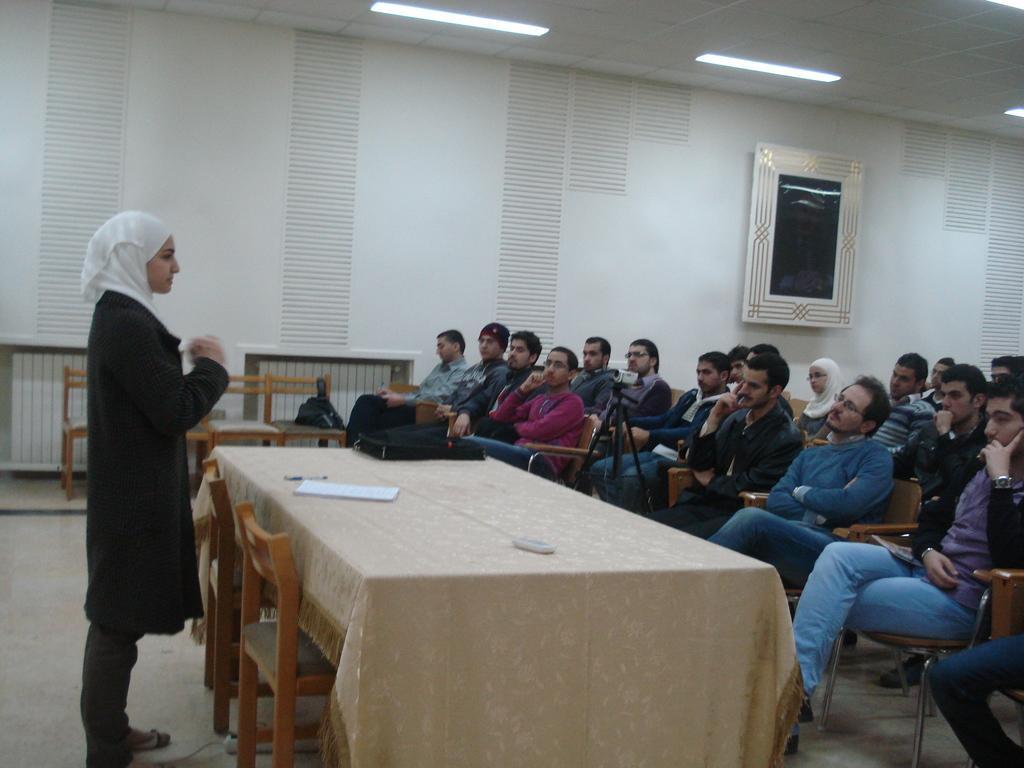How would you summarize this image in a sentence or two? In the image we can see there are lot of people who are sitting on chair and a woman is standing in front of them and they are looking at each other. 